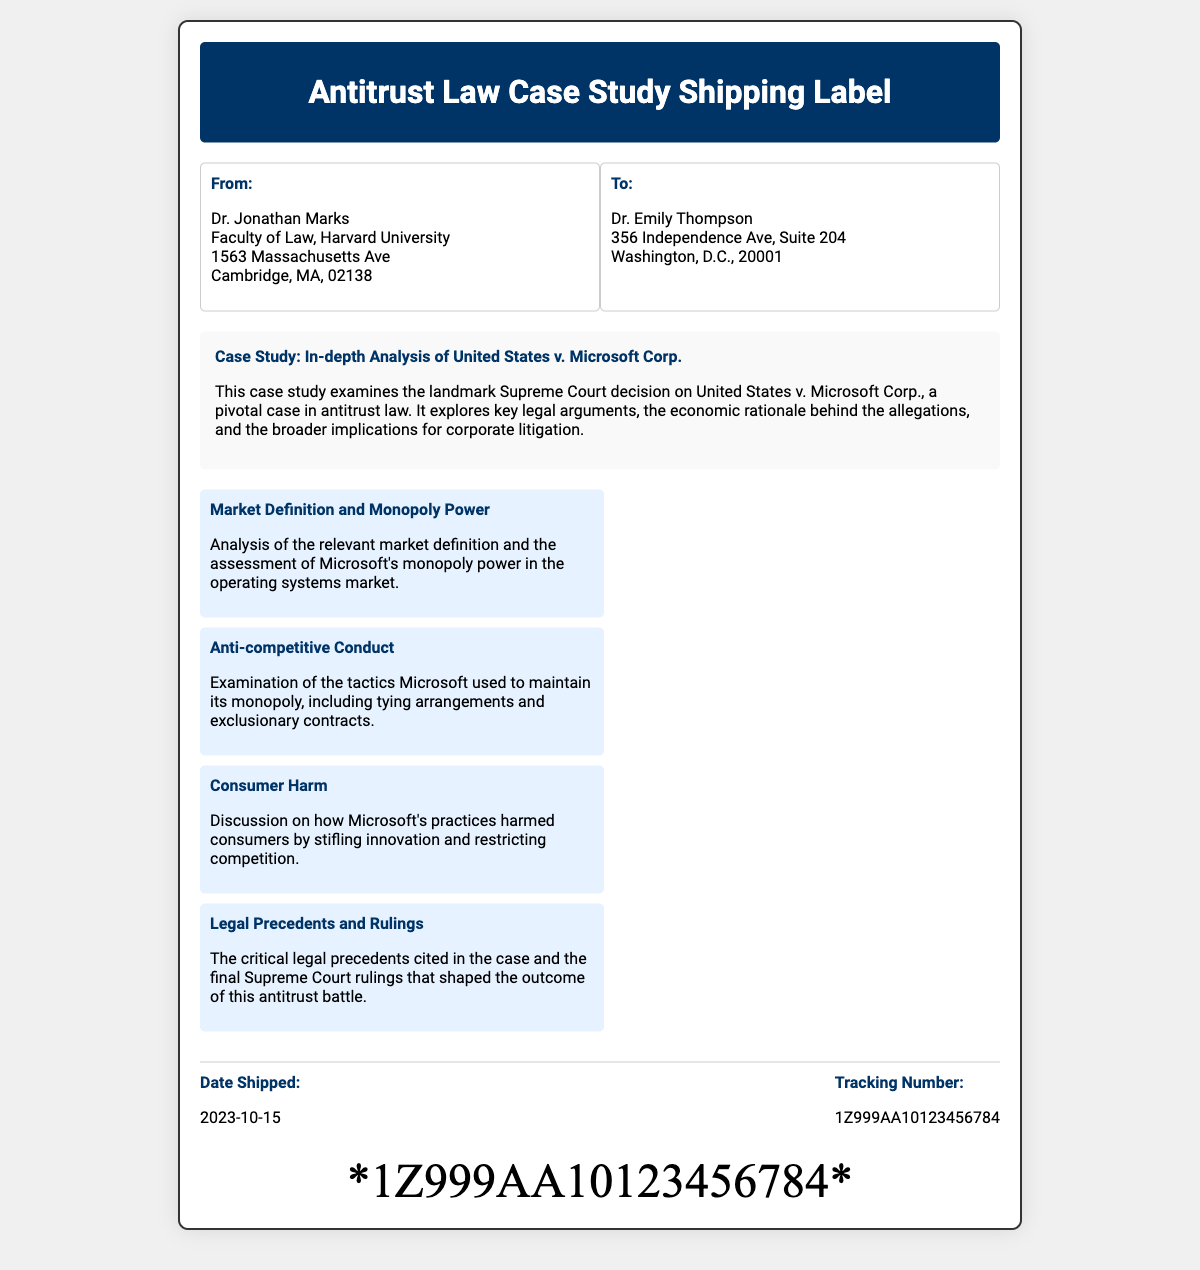What is the name of the Supreme Court case analyzed? The document mentions the case study focuses on "United States v. Microsoft Corp.”
Answer: United States v. Microsoft Corp Who is the sender of the shipping label? The sender's name and affiliation are listed, which is Dr. Jonathan Marks from Harvard University.
Answer: Dr. Jonathan Marks What is the tracking number provided? The document clearly states a tracking number which is necessary for shipment tracking purposes.
Answer: 1Z999AA10123456784 What is the date the item was shipped? The label specifies the shipping date for the item, which is an essential piece of information for logistics.
Answer: 2023-10-15 What is a key point regarding Microsoft's conduct? One of the key points addresses the actions Microsoft took to maintain its market position, indicating what is examined in the case study.
Answer: Anti-competitive Conduct What is the main focus of the case study? The main focus of the case study is outlined in the introductory paragraph of the document, indicating its overarching theme.
Answer: Antitrust law How many key points are listed in the document? The number of key points provides insight into the scope of analysis in the case study.
Answer: Four 